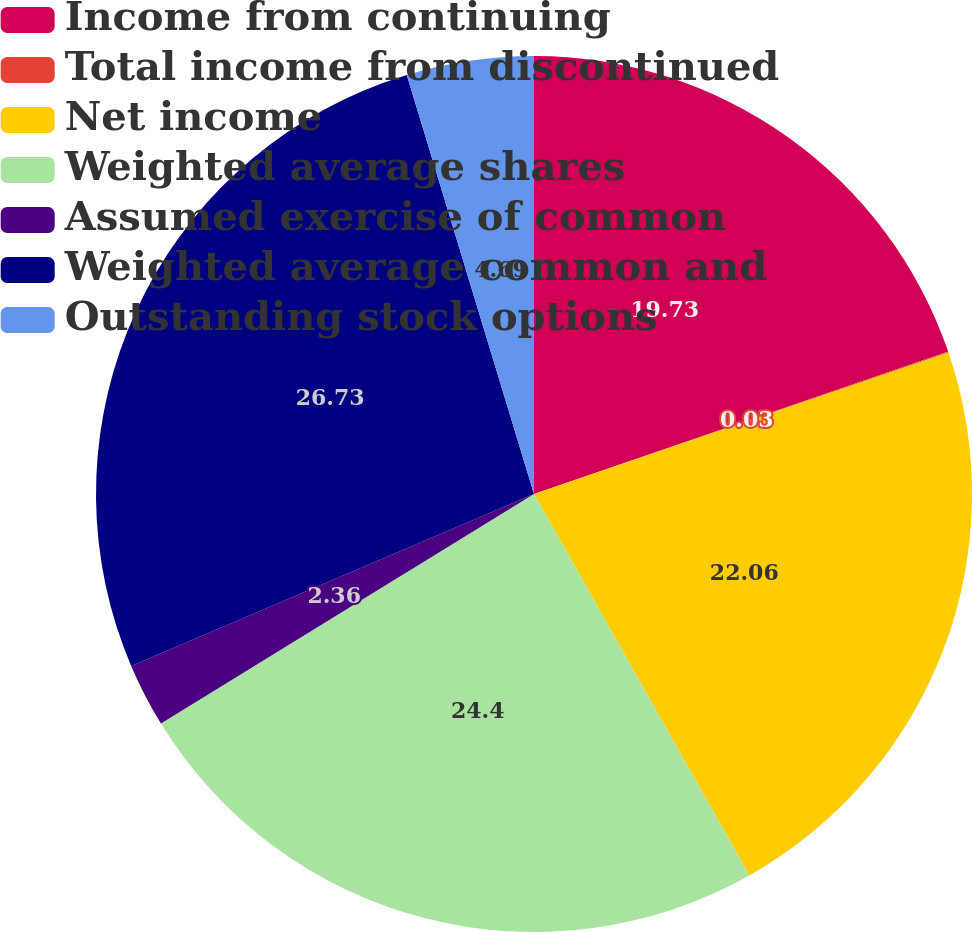Convert chart. <chart><loc_0><loc_0><loc_500><loc_500><pie_chart><fcel>Income from continuing<fcel>Total income from discontinued<fcel>Net income<fcel>Weighted average shares<fcel>Assumed exercise of common<fcel>Weighted average common and<fcel>Outstanding stock options<nl><fcel>19.73%<fcel>0.03%<fcel>22.06%<fcel>24.4%<fcel>2.36%<fcel>26.73%<fcel>4.69%<nl></chart> 